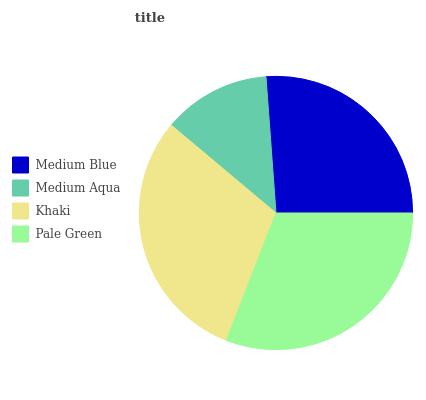Is Medium Aqua the minimum?
Answer yes or no. Yes. Is Pale Green the maximum?
Answer yes or no. Yes. Is Khaki the minimum?
Answer yes or no. No. Is Khaki the maximum?
Answer yes or no. No. Is Khaki greater than Medium Aqua?
Answer yes or no. Yes. Is Medium Aqua less than Khaki?
Answer yes or no. Yes. Is Medium Aqua greater than Khaki?
Answer yes or no. No. Is Khaki less than Medium Aqua?
Answer yes or no. No. Is Khaki the high median?
Answer yes or no. Yes. Is Medium Blue the low median?
Answer yes or no. Yes. Is Medium Aqua the high median?
Answer yes or no. No. Is Khaki the low median?
Answer yes or no. No. 